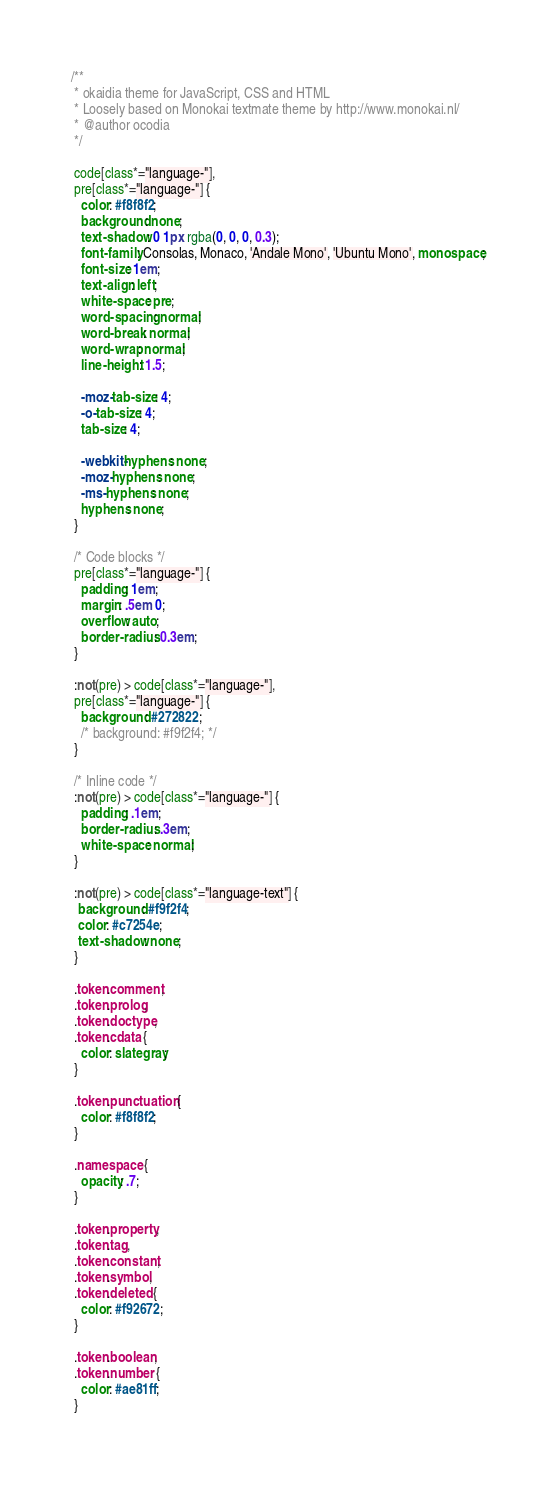<code> <loc_0><loc_0><loc_500><loc_500><_CSS_>/**
 * okaidia theme for JavaScript, CSS and HTML
 * Loosely based on Monokai textmate theme by http://www.monokai.nl/
 * @author ocodia
 */

 code[class*="language-"],
 pre[class*="language-"] {
   color: #f8f8f2;
   background: none;
   text-shadow: 0 1px rgba(0, 0, 0, 0.3);
   font-family: Consolas, Monaco, 'Andale Mono', 'Ubuntu Mono', monospace;
   font-size: 1em;
   text-align: left;
   white-space: pre;
   word-spacing: normal;
   word-break: normal;
   word-wrap: normal;
   line-height: 1.5;
 
   -moz-tab-size: 4;
   -o-tab-size: 4;
   tab-size: 4;
 
   -webkit-hyphens: none;
   -moz-hyphens: none;
   -ms-hyphens: none;
   hyphens: none;
 }
 
 /* Code blocks */
 pre[class*="language-"] {
   padding: 1em;
   margin: .5em 0;
   overflow: auto;
   border-radius: 0.3em;
 }
 
 :not(pre) > code[class*="language-"],
 pre[class*="language-"] {
   background: #272822;
   /* background: #f9f2f4; */
 }
 
 /* Inline code */
 :not(pre) > code[class*="language-"] {
   padding: .1em;
   border-radius: .3em;
   white-space: normal;
 }

 :not(pre) > code[class*="language-text"] {
  background: #f9f2f4;
  color: #c7254e;
  text-shadow: none;
 }
 
 .token.comment,
 .token.prolog,
 .token.doctype,
 .token.cdata {
   color: slategray;
 }
 
 .token.punctuation {
   color: #f8f8f2;
 }
 
 .namespace {
   opacity: .7;
 }
 
 .token.property,
 .token.tag,
 .token.constant,
 .token.symbol,
 .token.deleted {
   color: #f92672;
 }
 
 .token.boolean,
 .token.number {
   color: #ae81ff;
 }</code> 